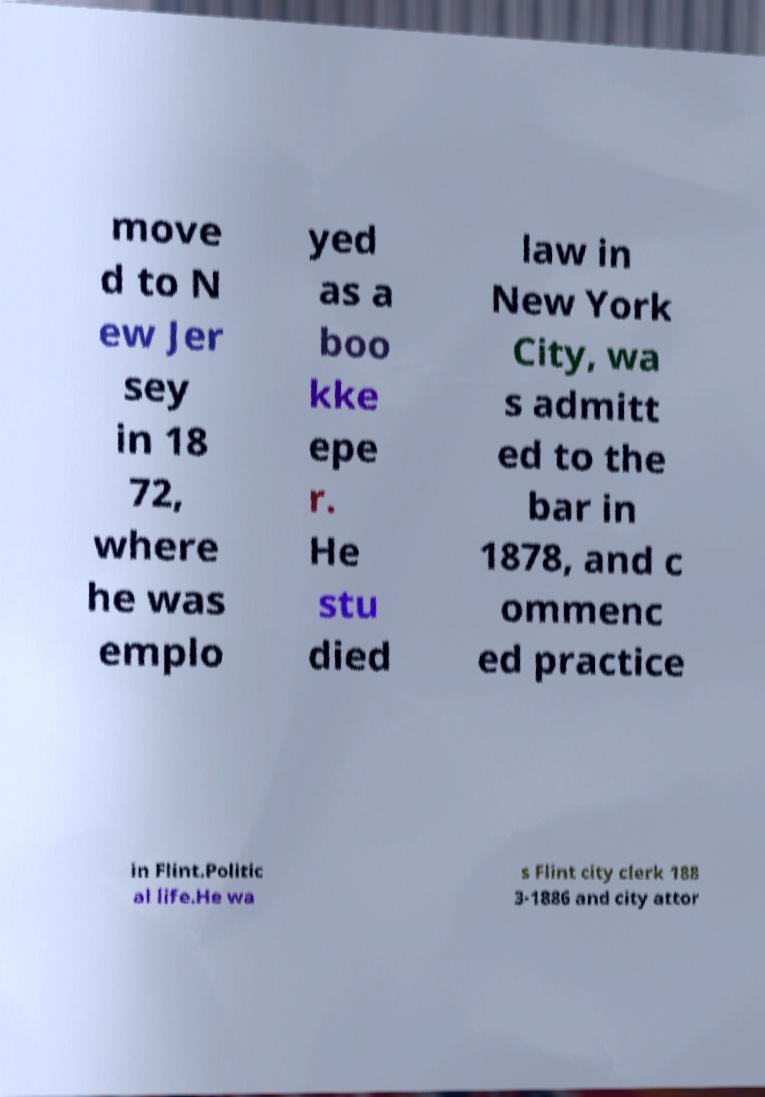There's text embedded in this image that I need extracted. Can you transcribe it verbatim? move d to N ew Jer sey in 18 72, where he was emplo yed as a boo kke epe r. He stu died law in New York City, wa s admitt ed to the bar in 1878, and c ommenc ed practice in Flint.Politic al life.He wa s Flint city clerk 188 3-1886 and city attor 